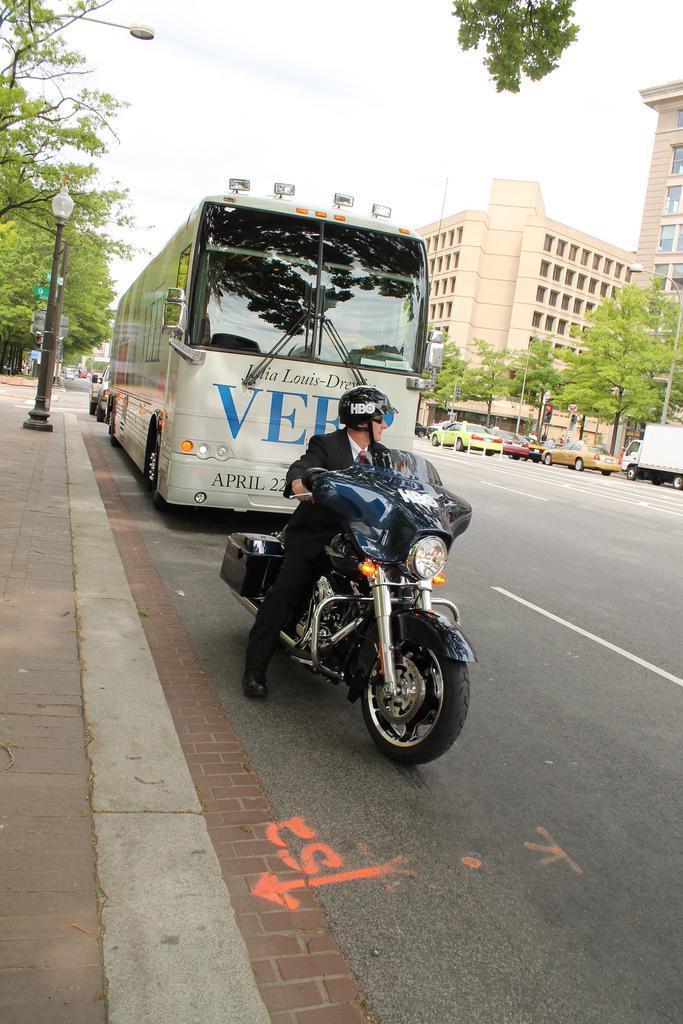How many yellow cars are driving on the street?
Give a very brief answer. 1. 